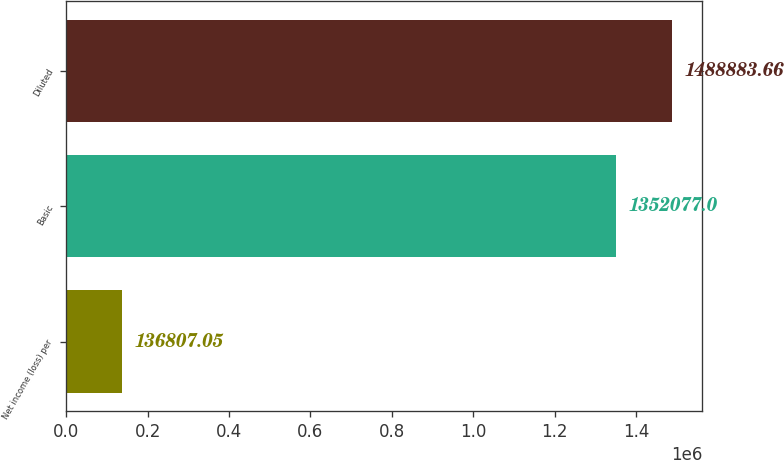<chart> <loc_0><loc_0><loc_500><loc_500><bar_chart><fcel>Net income (loss) per<fcel>Basic<fcel>Diluted<nl><fcel>136807<fcel>1.35208e+06<fcel>1.48888e+06<nl></chart> 